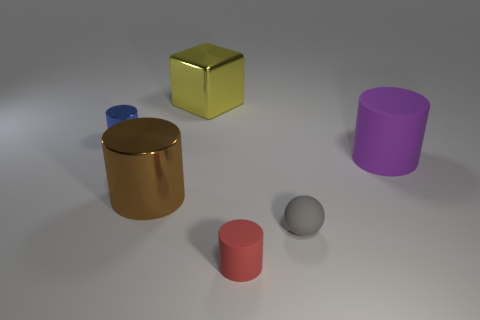The brown cylinder that is the same material as the yellow block is what size?
Ensure brevity in your answer.  Large. Is the size of the thing left of the large brown thing the same as the matte cylinder in front of the purple rubber thing?
Give a very brief answer. Yes. How many tiny things are red cylinders or matte objects?
Ensure brevity in your answer.  2. What is the material of the tiny cylinder in front of the small cylinder behind the small red cylinder?
Your response must be concise. Rubber. Is there a blue object that has the same material as the yellow object?
Offer a terse response. Yes. Is the material of the blue thing the same as the big cylinder to the left of the gray ball?
Give a very brief answer. Yes. There is a shiny cylinder that is the same size as the shiny block; what color is it?
Make the answer very short. Brown. What is the size of the metallic thing that is to the left of the large metal thing that is left of the big yellow metallic block?
Provide a short and direct response. Small. There is a large cube; is it the same color as the shiny thing that is on the left side of the large brown metallic thing?
Keep it short and to the point. No. Are there fewer large matte cylinders in front of the brown shiny object than blue objects?
Provide a short and direct response. Yes. 